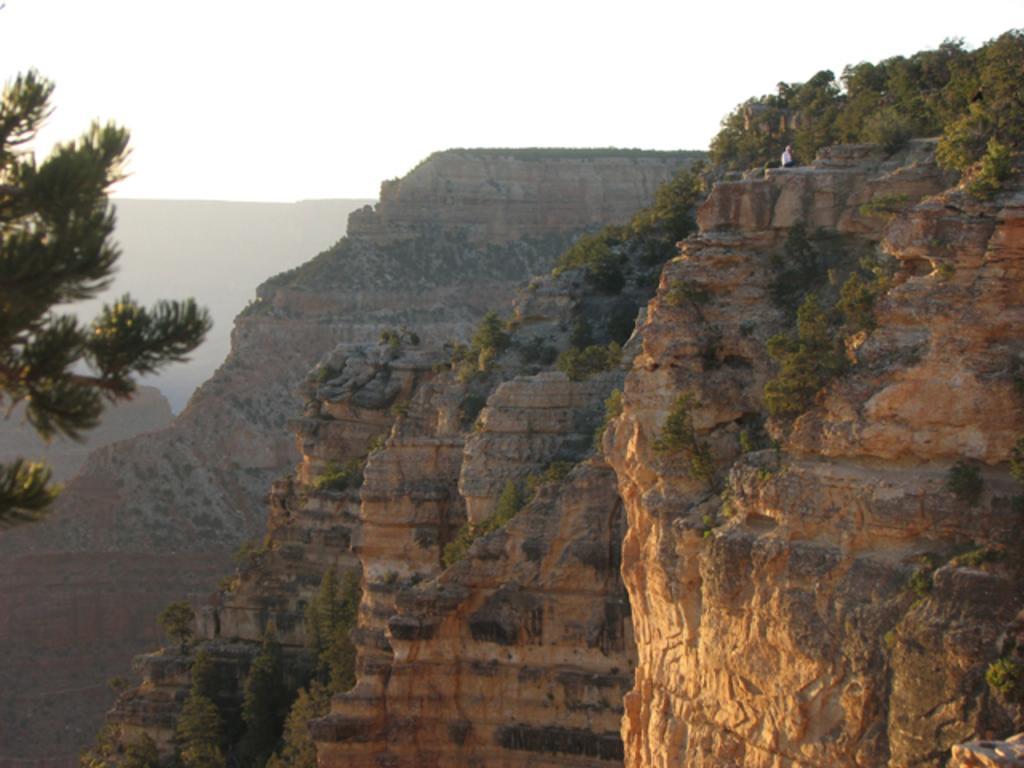Could you give a brief overview of what you see in this image? In this picture I can see the mountains. I can see trees. I can see clouds in the sky. 